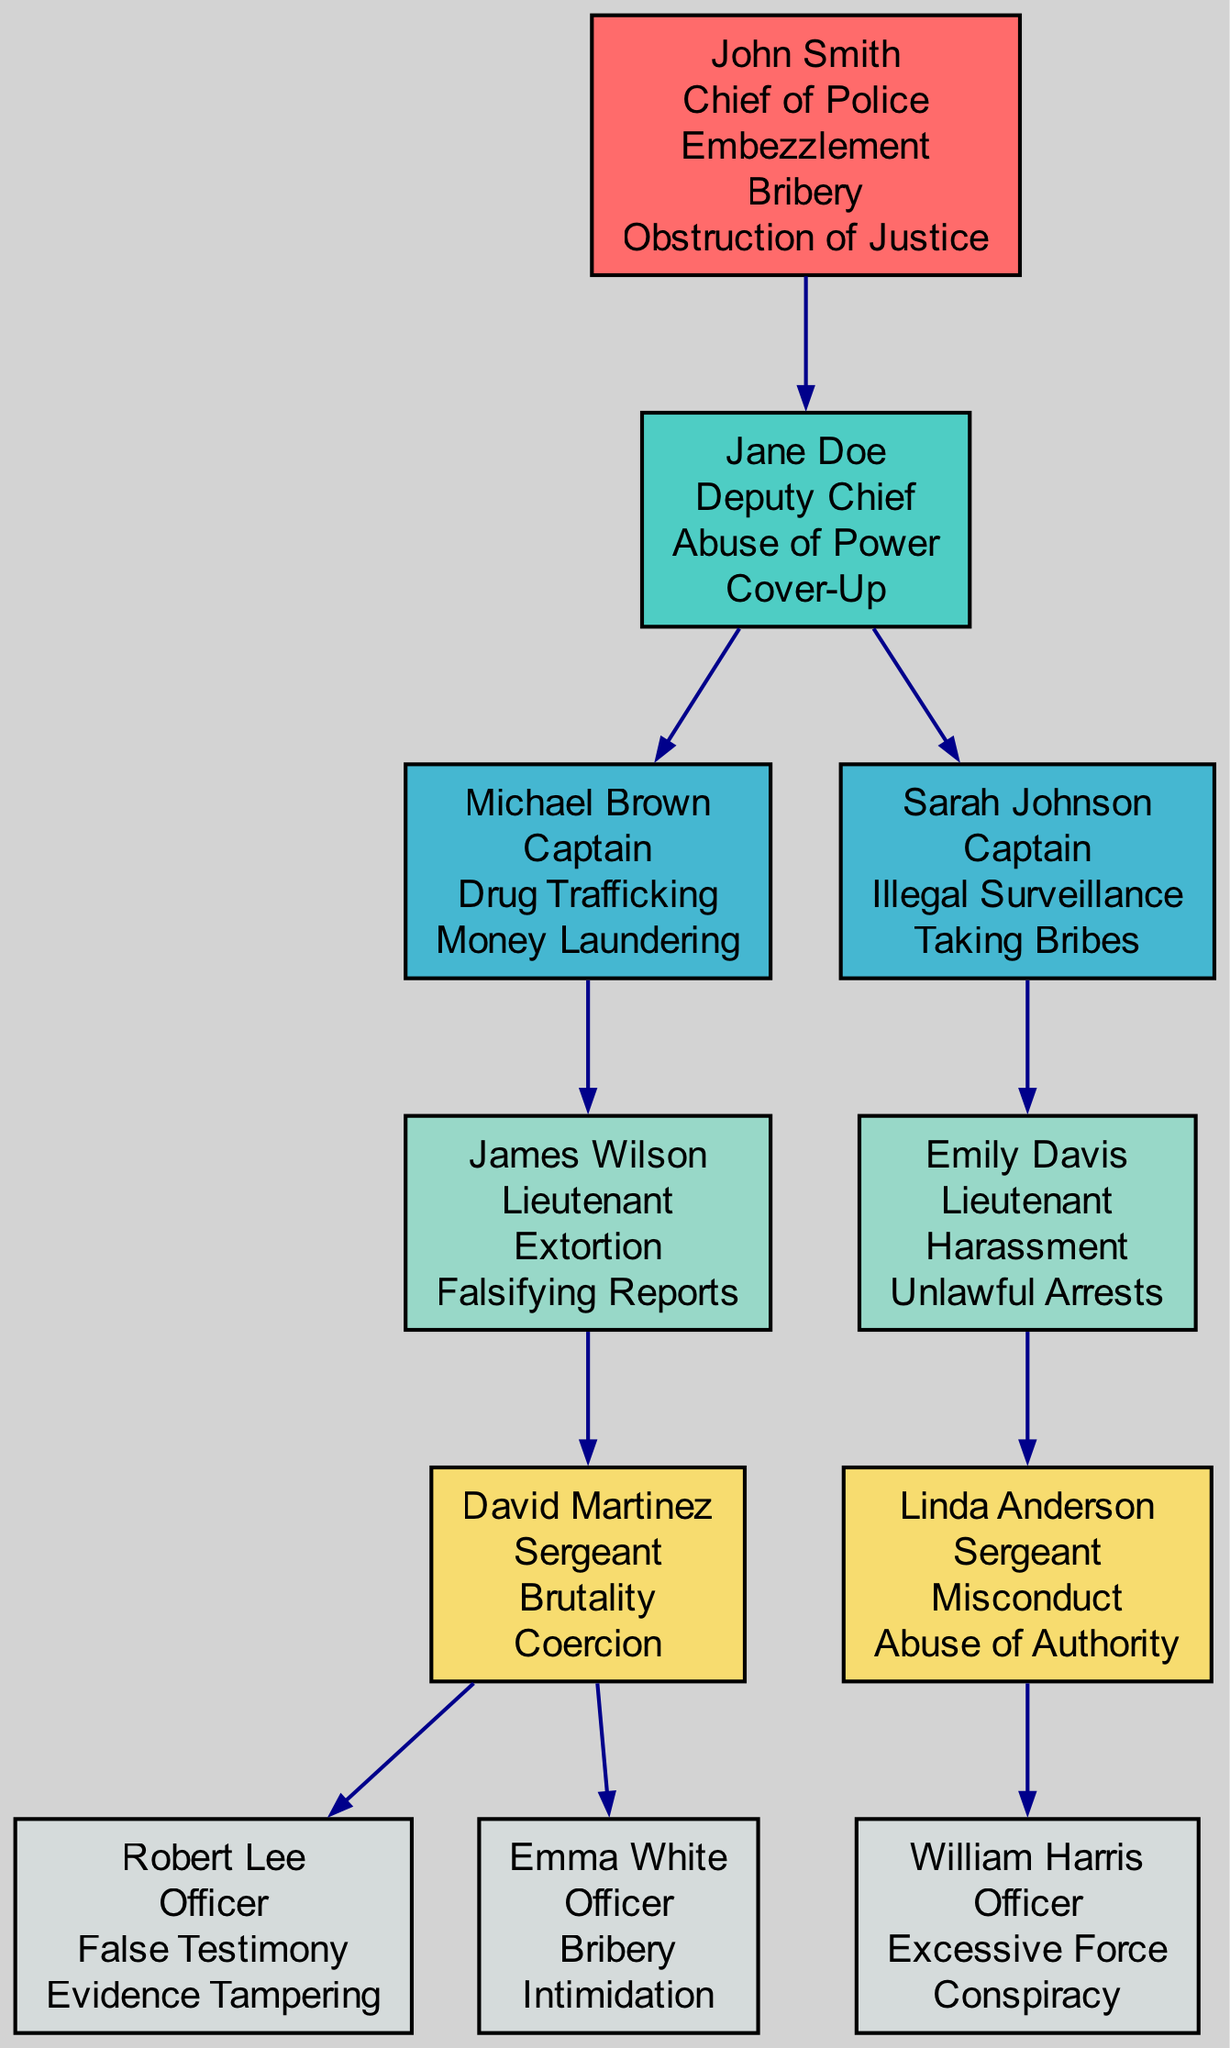What is the name of the Chief of Police? The diagram shows that the Chief of Police is labeled as "John Smith".
Answer: John Smith How many allegations does the Deputy Chief have? The Deputy Chief, Jane Doe, has two allegations: "Abuse of Power" and "Cover-Up", as shown in her node.
Answer: 2 Which Captain is connected to Lieutenant1? Lieutenant1 is connected to Captain1, which is indicated by the connections listed in the Captain1 node.
Answer: Captain1 What is the rank of Emily Davis? The diagram indicates that Emily Davis is labeled as a "Lieutenant", which is part of her node.
Answer: Lieutenant What are the allegations of Officer3? Officer3, William Harris, has two allegations listed: "Excessive Force" and "Conspiracy", found in his node.
Answer: Excessive Force, Conspiracy How many nodes are within the Middle Management category? There are three nodes under Middle Management: Deputy Chief, Captain1, and Captain2, as visually represented in that section of the diagram.
Answer: 3 Which rank is associated with the most allegations? Looking across the diagram, the Chief of Police has three allegations, which is the highest number compared to other ranks.
Answer: Chief of Police Who is connected to Sergeant2? The node for Sergeant2 indicates that she is connected to Officer3, so that is the answer.
Answer: Officer3 What is the connection between Jane Doe and Michael Brown? Jane Doe, as the Deputy Chief, has a direct connection to Michael Brown, which is displayed in the edge from DeputyChief to Captain1.
Answer: Captain1 